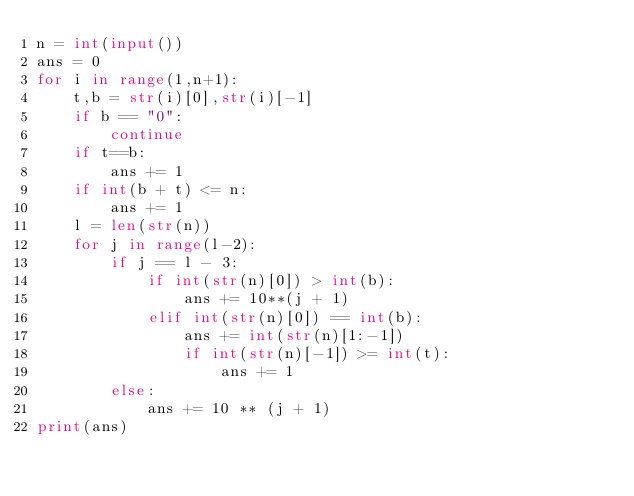<code> <loc_0><loc_0><loc_500><loc_500><_Python_>n = int(input())
ans = 0
for i in range(1,n+1):
    t,b = str(i)[0],str(i)[-1]
    if b == "0":
        continue
    if t==b:
        ans += 1
    if int(b + t) <= n:
        ans += 1
    l = len(str(n))
    for j in range(l-2):
        if j == l - 3:
            if int(str(n)[0]) > int(b):
                ans += 10**(j + 1)
            elif int(str(n)[0]) == int(b):
                ans += int(str(n)[1:-1])
                if int(str(n)[-1]) >= int(t):
                    ans += 1
        else:
            ans += 10 ** (j + 1)
print(ans)</code> 